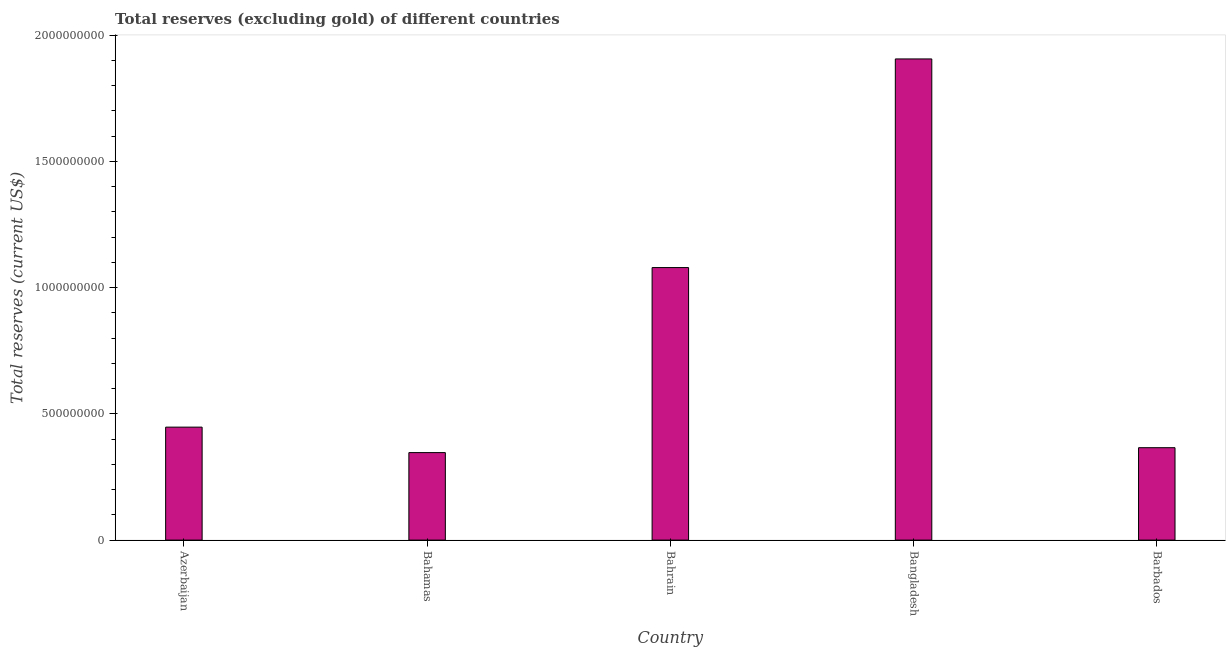Does the graph contain any zero values?
Your answer should be very brief. No. What is the title of the graph?
Offer a terse response. Total reserves (excluding gold) of different countries. What is the label or title of the Y-axis?
Provide a short and direct response. Total reserves (current US$). What is the total reserves (excluding gold) in Barbados?
Provide a short and direct response. 3.66e+08. Across all countries, what is the maximum total reserves (excluding gold)?
Offer a very short reply. 1.91e+09. Across all countries, what is the minimum total reserves (excluding gold)?
Ensure brevity in your answer.  3.47e+08. In which country was the total reserves (excluding gold) maximum?
Ensure brevity in your answer.  Bangladesh. In which country was the total reserves (excluding gold) minimum?
Provide a succinct answer. Bahamas. What is the sum of the total reserves (excluding gold)?
Provide a short and direct response. 4.14e+09. What is the difference between the total reserves (excluding gold) in Azerbaijan and Bangladesh?
Your answer should be very brief. -1.46e+09. What is the average total reserves (excluding gold) per country?
Keep it short and to the point. 8.29e+08. What is the median total reserves (excluding gold)?
Make the answer very short. 4.47e+08. What is the ratio of the total reserves (excluding gold) in Bangladesh to that in Barbados?
Keep it short and to the point. 5.21. Is the difference between the total reserves (excluding gold) in Bahrain and Barbados greater than the difference between any two countries?
Make the answer very short. No. What is the difference between the highest and the second highest total reserves (excluding gold)?
Provide a succinct answer. 8.26e+08. Is the sum of the total reserves (excluding gold) in Bahrain and Bangladesh greater than the maximum total reserves (excluding gold) across all countries?
Your response must be concise. Yes. What is the difference between the highest and the lowest total reserves (excluding gold)?
Ensure brevity in your answer.  1.56e+09. In how many countries, is the total reserves (excluding gold) greater than the average total reserves (excluding gold) taken over all countries?
Keep it short and to the point. 2. How many bars are there?
Your answer should be very brief. 5. How many countries are there in the graph?
Ensure brevity in your answer.  5. Are the values on the major ticks of Y-axis written in scientific E-notation?
Give a very brief answer. No. What is the Total reserves (current US$) in Azerbaijan?
Make the answer very short. 4.47e+08. What is the Total reserves (current US$) of Bahamas?
Ensure brevity in your answer.  3.47e+08. What is the Total reserves (current US$) of Bahrain?
Give a very brief answer. 1.08e+09. What is the Total reserves (current US$) of Bangladesh?
Provide a short and direct response. 1.91e+09. What is the Total reserves (current US$) of Barbados?
Provide a short and direct response. 3.66e+08. What is the difference between the Total reserves (current US$) in Azerbaijan and Bahamas?
Your response must be concise. 1.01e+08. What is the difference between the Total reserves (current US$) in Azerbaijan and Bahrain?
Your answer should be very brief. -6.32e+08. What is the difference between the Total reserves (current US$) in Azerbaijan and Bangladesh?
Ensure brevity in your answer.  -1.46e+09. What is the difference between the Total reserves (current US$) in Azerbaijan and Barbados?
Your answer should be very brief. 8.14e+07. What is the difference between the Total reserves (current US$) in Bahamas and Bahrain?
Offer a terse response. -7.33e+08. What is the difference between the Total reserves (current US$) in Bahamas and Bangladesh?
Ensure brevity in your answer.  -1.56e+09. What is the difference between the Total reserves (current US$) in Bahamas and Barbados?
Your response must be concise. -1.94e+07. What is the difference between the Total reserves (current US$) in Bahrain and Bangladesh?
Your answer should be very brief. -8.26e+08. What is the difference between the Total reserves (current US$) in Bahrain and Barbados?
Provide a succinct answer. 7.13e+08. What is the difference between the Total reserves (current US$) in Bangladesh and Barbados?
Ensure brevity in your answer.  1.54e+09. What is the ratio of the Total reserves (current US$) in Azerbaijan to that in Bahamas?
Provide a succinct answer. 1.29. What is the ratio of the Total reserves (current US$) in Azerbaijan to that in Bahrain?
Offer a very short reply. 0.41. What is the ratio of the Total reserves (current US$) in Azerbaijan to that in Bangladesh?
Give a very brief answer. 0.23. What is the ratio of the Total reserves (current US$) in Azerbaijan to that in Barbados?
Offer a very short reply. 1.22. What is the ratio of the Total reserves (current US$) in Bahamas to that in Bahrain?
Keep it short and to the point. 0.32. What is the ratio of the Total reserves (current US$) in Bahamas to that in Bangladesh?
Make the answer very short. 0.18. What is the ratio of the Total reserves (current US$) in Bahamas to that in Barbados?
Keep it short and to the point. 0.95. What is the ratio of the Total reserves (current US$) in Bahrain to that in Bangladesh?
Provide a succinct answer. 0.57. What is the ratio of the Total reserves (current US$) in Bahrain to that in Barbados?
Give a very brief answer. 2.95. What is the ratio of the Total reserves (current US$) in Bangladesh to that in Barbados?
Provide a short and direct response. 5.21. 